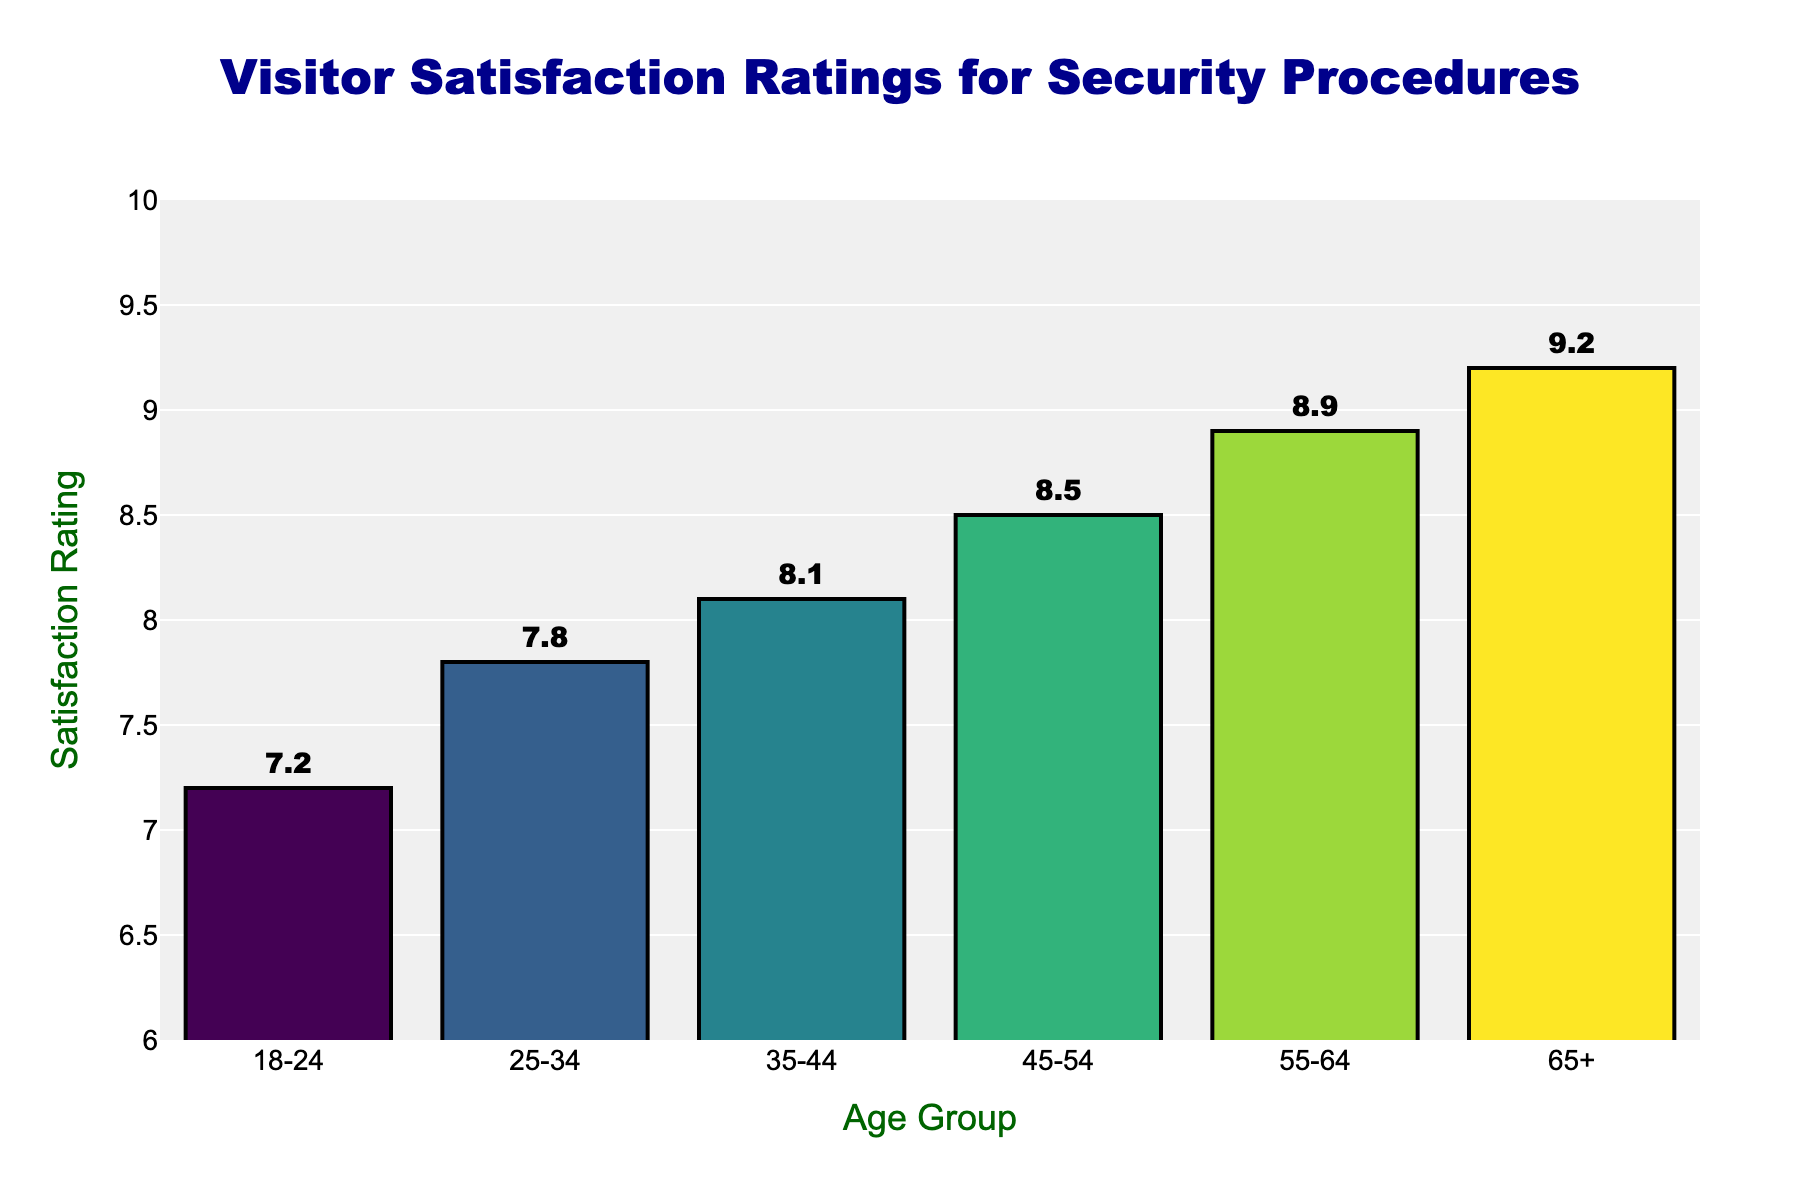Which age group has the highest satisfaction rating? The age group with the highest bar represents the highest satisfaction rating. The bar corresponding to the age group "65+" is the tallest.
Answer: 65+ What is the difference in satisfaction ratings between the 18-24 and 65+ age groups? Find the satisfaction ratings of both age groups and subtract the lower value from the higher value. Satisfaction rating for 18-24 is 7.2, and for 65+ it is 9.2. The difference is 9.2 - 7.2 = 2.0
Answer: 2.0 How many age groups have a satisfaction rating of 8.0 or higher? Count the number of bars with satisfaction ratings of 8.0 or higher. The age groups 35-44, 45-54, 55-64, and 65+ have ratings of 8.1, 8.5, 8.9, and 9.2 respectively.
Answer: 4 Which two adjacent age groups have the smallest difference in their satisfaction ratings? Calculate the differences between adjacent age groups and find the smallest difference. The smallest difference is between age group 25-34 (7.8) and age group 35-44 (8.1), giving a difference of 8.1 - 7.8 = 0.3.
Answer: 25-34 and 35-44 What is the average satisfaction rating across all age groups? Add the satisfaction ratings and divide by the number of age groups. (7.2 + 7.8 + 8.1 + 8.5 + 8.9 + 9.2) / 6 = 49.7 / 6 ≈ 8.28
Answer: 8.28 Rank the age groups from highest to lowest satisfaction rating. Order the age groups based on their bar heights (satisfaction ratings). 65+ (9.2) > 55-64 (8.9) > 45-54 (8.5) > 35-44 (8.1) > 25-34 (7.8) > 18-24 (7.2).
Answer: 65+, 55-64, 45-54, 35-44, 25-34, 18-24 What is the median satisfaction rating? List the satisfaction ratings in ascending order and find the middle value. 7.2, 7.8, 8.1, 8.5, 8.9, 9.2. The middle values are 8.1 and 8.5, so the median is (8.1 + 8.5) / 2 = 8.3.
Answer: 8.3 Do any age groups have equal satisfaction ratings? Compare the satisfaction ratings of all age groups to see if any are equal. All satisfaction ratings are distinct.
Answer: No 